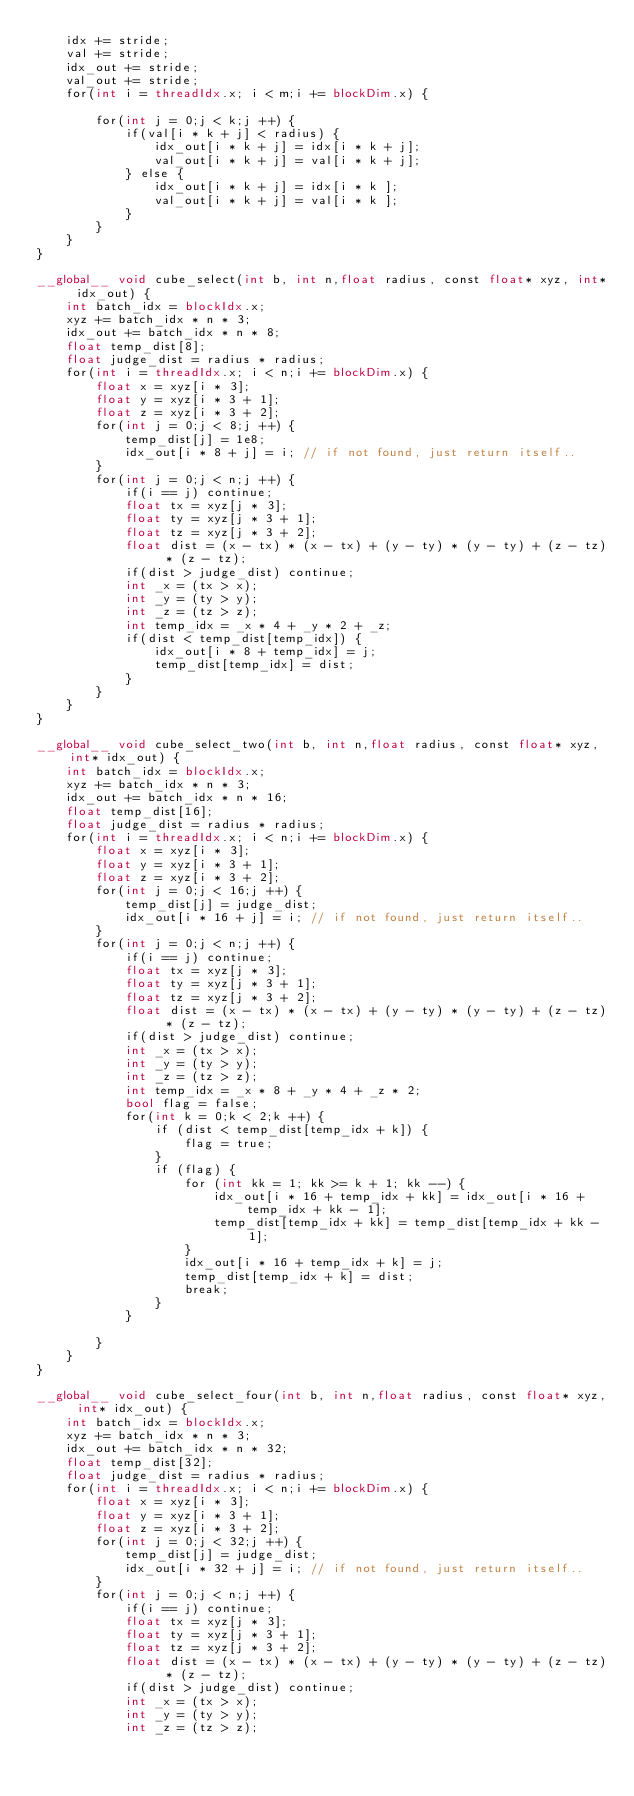Convert code to text. <code><loc_0><loc_0><loc_500><loc_500><_Cuda_>    idx += stride;
    val += stride;
    idx_out += stride;
    val_out += stride;
    for(int i = threadIdx.x; i < m;i += blockDim.x) {

        for(int j = 0;j < k;j ++) {
            if(val[i * k + j] < radius) {
                idx_out[i * k + j] = idx[i * k + j];
                val_out[i * k + j] = val[i * k + j];
            } else {
                idx_out[i * k + j] = idx[i * k ];
                val_out[i * k + j] = val[i * k ];
            }
        }
    }
}

__global__ void cube_select(int b, int n,float radius, const float* xyz, int* idx_out) {
    int batch_idx = blockIdx.x;
    xyz += batch_idx * n * 3;
    idx_out += batch_idx * n * 8;
    float temp_dist[8];
    float judge_dist = radius * radius;
    for(int i = threadIdx.x; i < n;i += blockDim.x) {
        float x = xyz[i * 3];
        float y = xyz[i * 3 + 1];
        float z = xyz[i * 3 + 2];
        for(int j = 0;j < 8;j ++) {
            temp_dist[j] = 1e8;
            idx_out[i * 8 + j] = i; // if not found, just return itself..
        }
        for(int j = 0;j < n;j ++) {
            if(i == j) continue;
            float tx = xyz[j * 3];
            float ty = xyz[j * 3 + 1];
            float tz = xyz[j * 3 + 2];
            float dist = (x - tx) * (x - tx) + (y - ty) * (y - ty) + (z - tz) * (z - tz);
            if(dist > judge_dist) continue;
            int _x = (tx > x);
            int _y = (ty > y);
            int _z = (tz > z);
            int temp_idx = _x * 4 + _y * 2 + _z;
            if(dist < temp_dist[temp_idx]) {
                idx_out[i * 8 + temp_idx] = j;
                temp_dist[temp_idx] = dist;
            }
        }
    }
}

__global__ void cube_select_two(int b, int n,float radius, const float* xyz, int* idx_out) {
    int batch_idx = blockIdx.x;
    xyz += batch_idx * n * 3;
    idx_out += batch_idx * n * 16;
    float temp_dist[16];
    float judge_dist = radius * radius;
    for(int i = threadIdx.x; i < n;i += blockDim.x) {
        float x = xyz[i * 3];
        float y = xyz[i * 3 + 1];
        float z = xyz[i * 3 + 2];
        for(int j = 0;j < 16;j ++) {
            temp_dist[j] = judge_dist;
            idx_out[i * 16 + j] = i; // if not found, just return itself..
        }
        for(int j = 0;j < n;j ++) {
            if(i == j) continue;
            float tx = xyz[j * 3];
            float ty = xyz[j * 3 + 1];
            float tz = xyz[j * 3 + 2];
            float dist = (x - tx) * (x - tx) + (y - ty) * (y - ty) + (z - tz) * (z - tz);
            if(dist > judge_dist) continue;
            int _x = (tx > x);
            int _y = (ty > y);
            int _z = (tz > z);
            int temp_idx = _x * 8 + _y * 4 + _z * 2;
            bool flag = false;
            for(int k = 0;k < 2;k ++) {
                if (dist < temp_dist[temp_idx + k]) {
                    flag = true;
                }
                if (flag) {
                    for (int kk = 1; kk >= k + 1; kk --) {
                        idx_out[i * 16 + temp_idx + kk] = idx_out[i * 16 + temp_idx + kk - 1];
                        temp_dist[temp_idx + kk] = temp_dist[temp_idx + kk - 1];
                    }
                    idx_out[i * 16 + temp_idx + k] = j;
                    temp_dist[temp_idx + k] = dist;
                    break;
                }
            }

        }
    }
}

__global__ void cube_select_four(int b, int n,float radius, const float* xyz, int* idx_out) {
    int batch_idx = blockIdx.x;
    xyz += batch_idx * n * 3;
    idx_out += batch_idx * n * 32;
    float temp_dist[32];
    float judge_dist = radius * radius;
    for(int i = threadIdx.x; i < n;i += blockDim.x) {
        float x = xyz[i * 3];
        float y = xyz[i * 3 + 1];
        float z = xyz[i * 3 + 2];
        for(int j = 0;j < 32;j ++) {
            temp_dist[j] = judge_dist;
            idx_out[i * 32 + j] = i; // if not found, just return itself..
        }
        for(int j = 0;j < n;j ++) {
            if(i == j) continue;
            float tx = xyz[j * 3];
            float ty = xyz[j * 3 + 1];
            float tz = xyz[j * 3 + 2];
            float dist = (x - tx) * (x - tx) + (y - ty) * (y - ty) + (z - tz) * (z - tz);
            if(dist > judge_dist) continue;
            int _x = (tx > x);
            int _y = (ty > y);
            int _z = (tz > z);</code> 